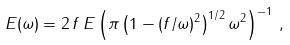<formula> <loc_0><loc_0><loc_500><loc_500>E ( \omega ) = { 2 \, f \, E } \left ( { \pi \left ( 1 - ( { f } / { \omega } ) ^ { 2 } \right ) ^ { 1 / 2 } \omega ^ { 2 } } \right ) ^ { - 1 } \, ,</formula> 